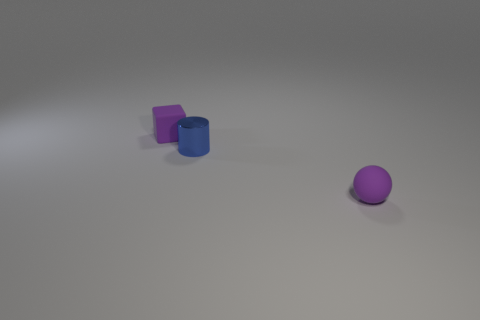There is a tiny purple matte object on the left side of the matte object that is in front of the tiny metal cylinder; is there a purple rubber sphere that is on the left side of it?
Offer a terse response. No. There is a tiny matte thing that is behind the tiny purple ball; how many cylinders are right of it?
Give a very brief answer. 1. What size is the purple thing right of the small matte thing behind the rubber thing that is on the right side of the small shiny cylinder?
Offer a terse response. Small. There is a shiny thing on the right side of the purple object behind the tiny purple matte sphere; what is its color?
Your response must be concise. Blue. How many other things are there of the same material as the ball?
Your answer should be compact. 1. How many other objects are there of the same color as the rubber cube?
Give a very brief answer. 1. What is the tiny purple thing behind the matte object right of the small metal object made of?
Ensure brevity in your answer.  Rubber. Are there any purple matte things?
Ensure brevity in your answer.  Yes. There is a purple rubber object that is to the left of the purple matte ball that is in front of the tiny blue metallic cylinder; how big is it?
Provide a succinct answer. Small. Is the number of purple balls that are behind the cylinder greater than the number of matte spheres to the right of the matte ball?
Your answer should be very brief. No. 